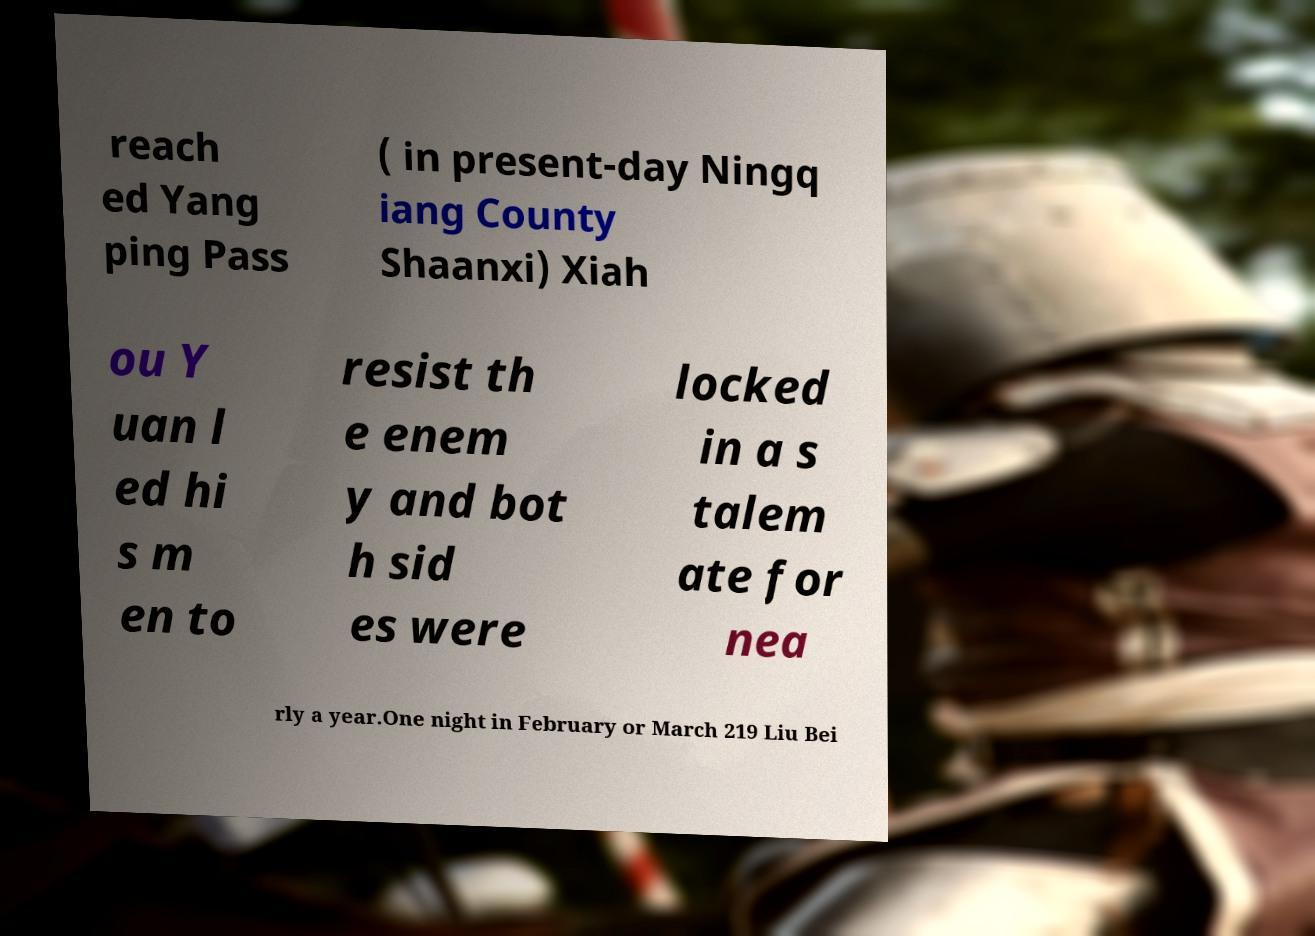Can you accurately transcribe the text from the provided image for me? reach ed Yang ping Pass ( in present-day Ningq iang County Shaanxi) Xiah ou Y uan l ed hi s m en to resist th e enem y and bot h sid es were locked in a s talem ate for nea rly a year.One night in February or March 219 Liu Bei 